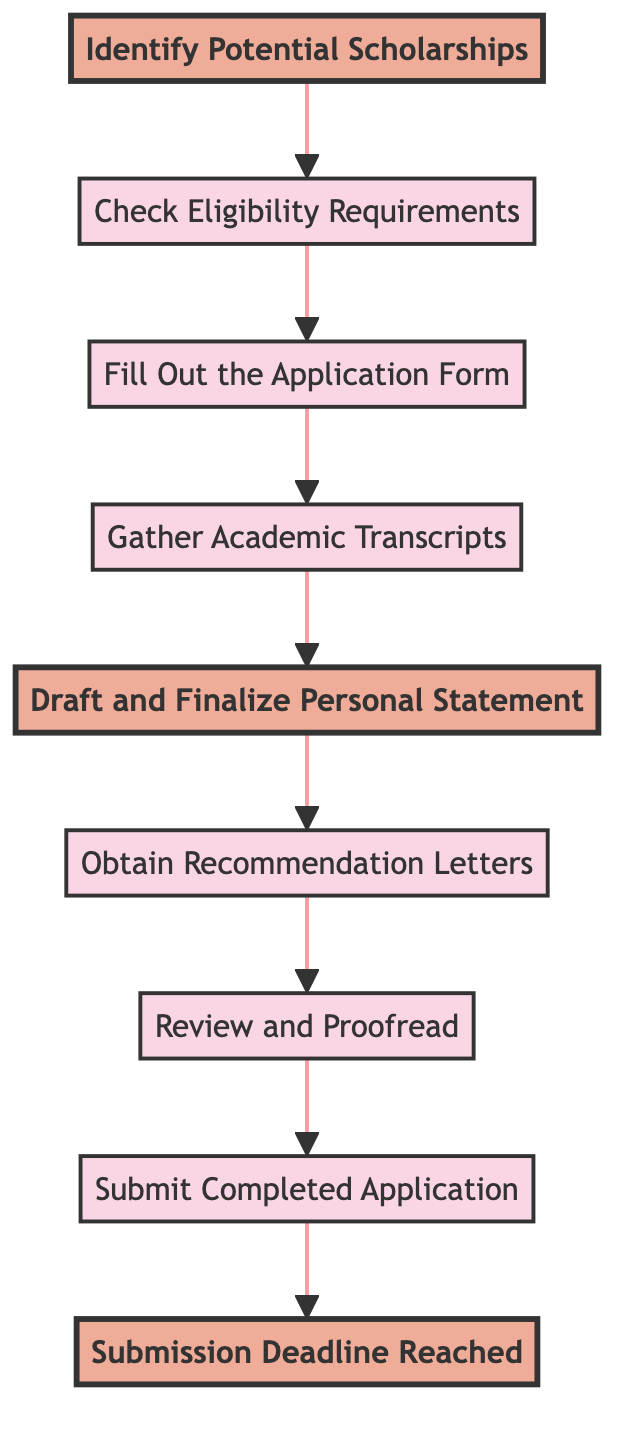What is the first step in the scholarship application process? The diagram indicates that the first step is "Identify Potential Scholarships," as it is the starting node in the flow.
Answer: Identify Potential Scholarships How many nodes are there in the diagram? By counting all the distinct steps depicted in the diagram, there are eight nodes related to the scholarship application process.
Answer: Eight What is the last step before the submission deadline? The last step before "Submission Deadline Reached" is "Submit Completed Application," which is also the final actionable item in the process.
Answer: Submit Completed Application Which step follows "Fill Out the Application Form"? The diagram shows that "Gather Academic Transcripts" is the next step after completing the application form, as indicated by the direct connection in the flowchart.
Answer: Gather Academic Transcripts What is required to be collected before proofreading? According to the diagram, "Obtain Recommendation Letters" must be completed before moving on to the "Review and Proofread" step.
Answer: Obtain Recommendation Letters How do the steps "Draft and Finalize Personal Statement" and "Gather Academic Transcripts" relate? "Draft and Finalize Personal Statement" follows "Gather Academic Transcripts," meaning that academic records are needed before drafting the personal statement, indicating a sequential relationship.
Answer: Sequential relationship What is a necessary action after "Check Eligibility Requirements"? After completing "Check Eligibility Requirements," the next necessary action is to "Fill Out the Application Form," which shows the progression of tasks.
Answer: Fill Out the Application Form What can you infer if someone has reached the "Submission Deadline Reached"? If someone has arrived at "Submission Deadline Reached," it implies that all prior steps have been completed and the application has been submitted on time.
Answer: All prior steps completed 